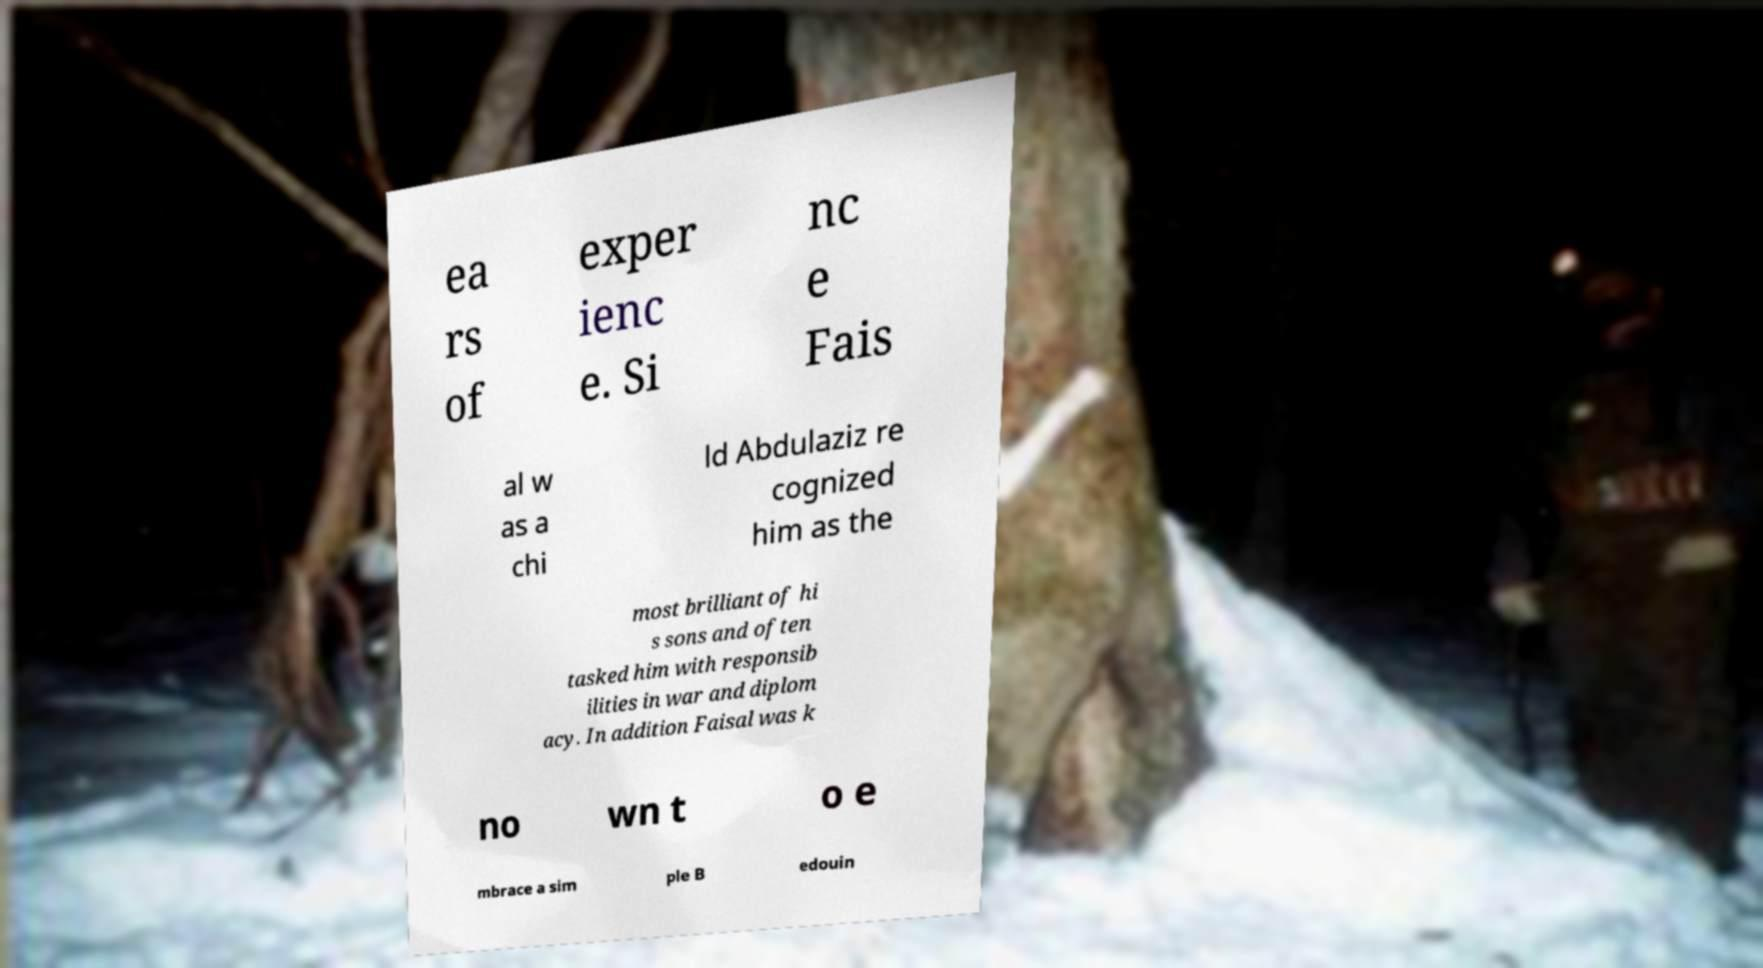There's text embedded in this image that I need extracted. Can you transcribe it verbatim? ea rs of exper ienc e. Si nc e Fais al w as a chi ld Abdulaziz re cognized him as the most brilliant of hi s sons and often tasked him with responsib ilities in war and diplom acy. In addition Faisal was k no wn t o e mbrace a sim ple B edouin 